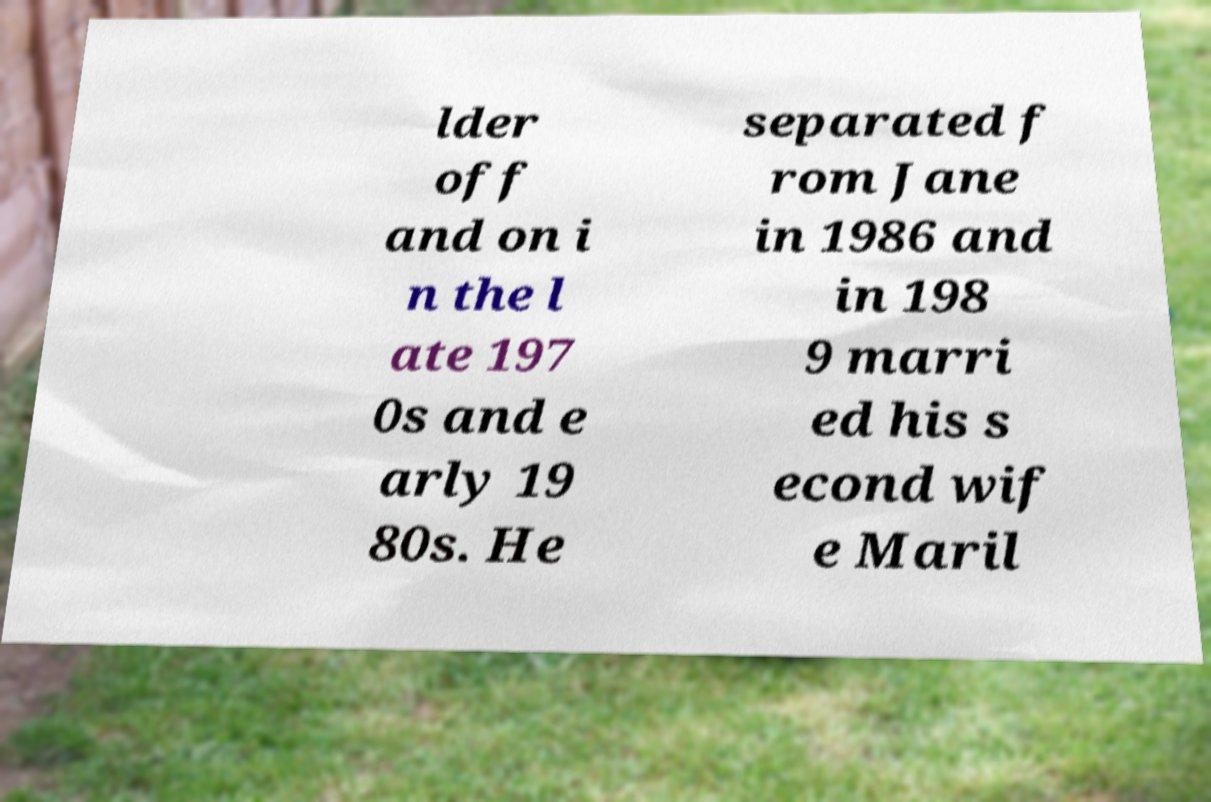There's text embedded in this image that I need extracted. Can you transcribe it verbatim? lder off and on i n the l ate 197 0s and e arly 19 80s. He separated f rom Jane in 1986 and in 198 9 marri ed his s econd wif e Maril 